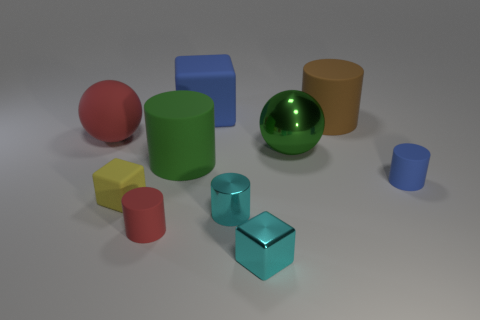Subtract all red cylinders. How many cylinders are left? 4 Subtract all rubber cubes. How many cubes are left? 1 Subtract all balls. How many objects are left? 8 Subtract all gray cylinders. Subtract all cyan cubes. How many cylinders are left? 5 Subtract all brown objects. Subtract all red balls. How many objects are left? 8 Add 4 red things. How many red things are left? 6 Add 10 large red blocks. How many large red blocks exist? 10 Subtract 0 brown spheres. How many objects are left? 10 